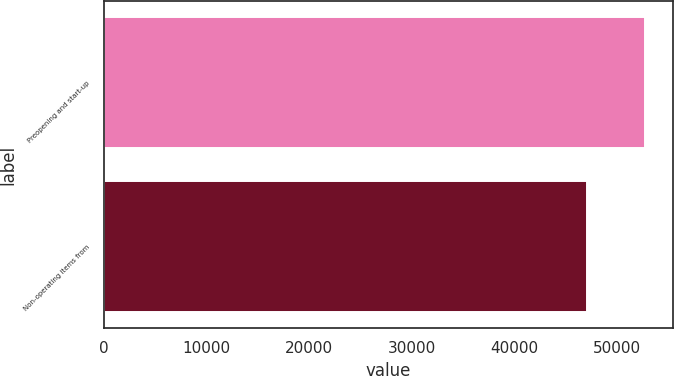Convert chart to OTSL. <chart><loc_0><loc_0><loc_500><loc_500><bar_chart><fcel>Preopening and start-up<fcel>Non-operating items from<nl><fcel>52824<fcel>47127<nl></chart> 